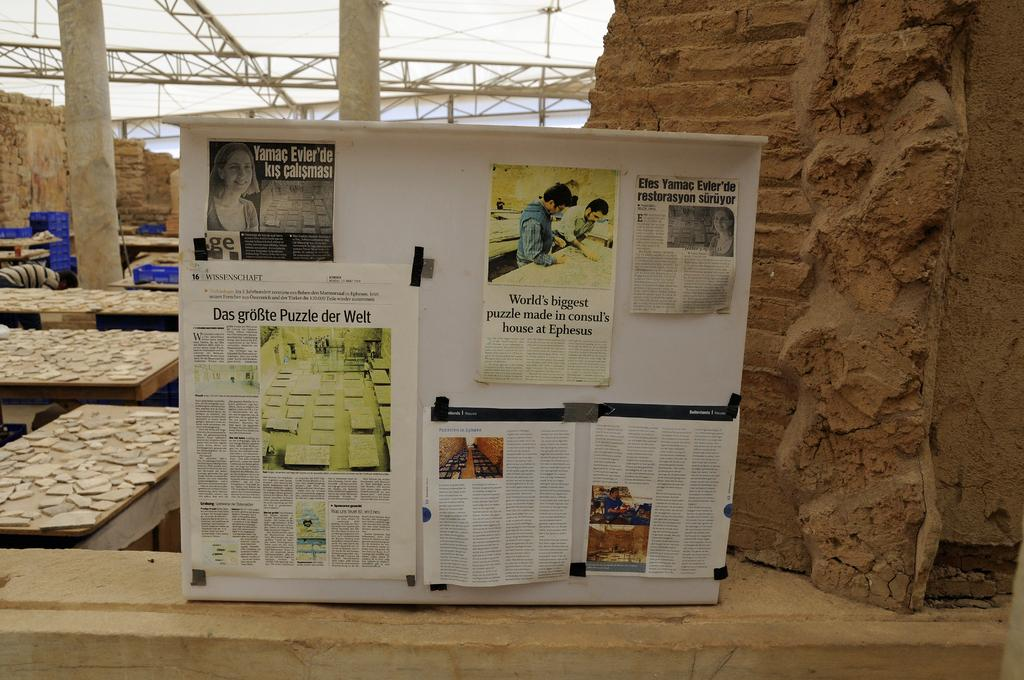Provide a one-sentence caption for the provided image. A board with newspapers tacked on it, one that talks about the 'word's biggest puzzle'. 